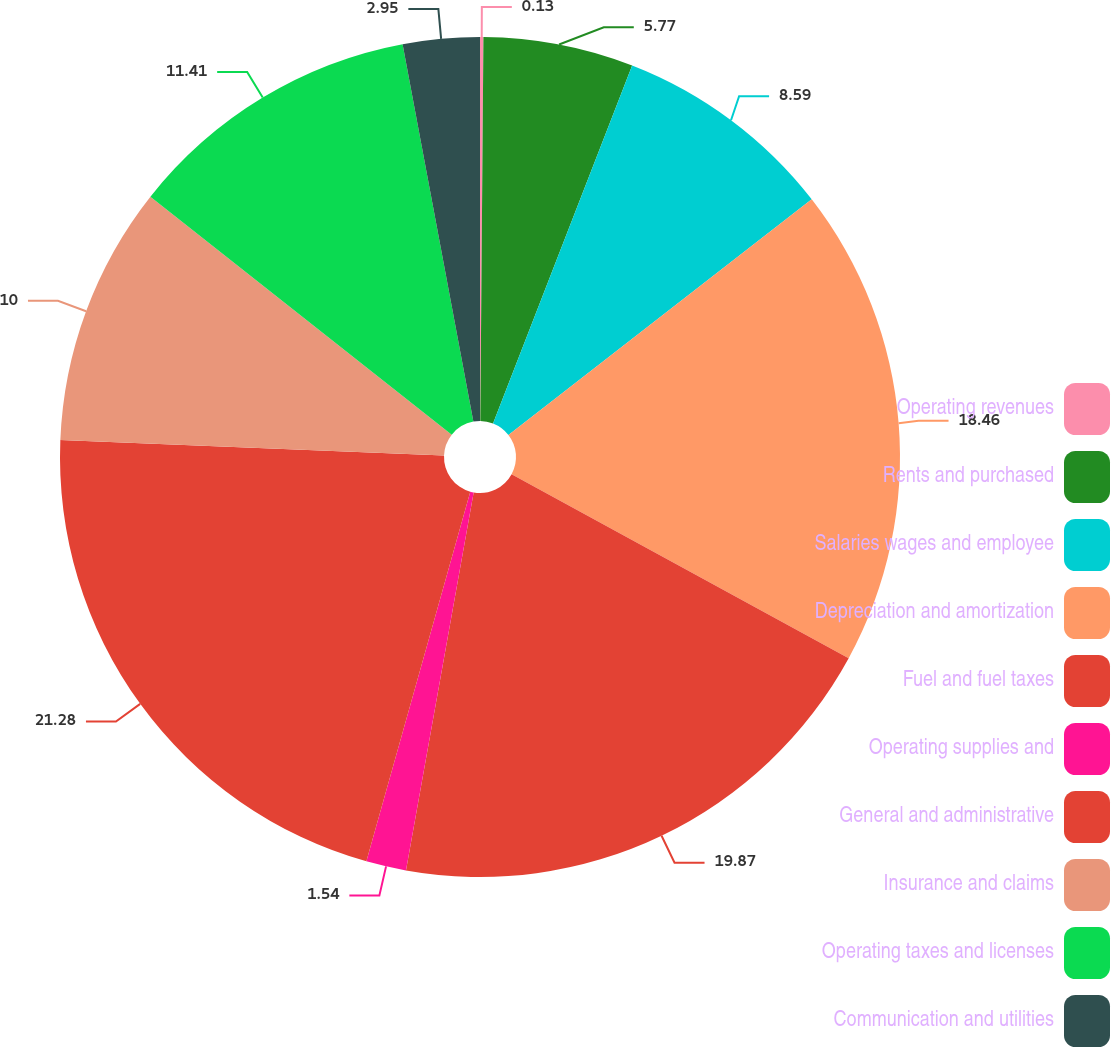Convert chart. <chart><loc_0><loc_0><loc_500><loc_500><pie_chart><fcel>Operating revenues<fcel>Rents and purchased<fcel>Salaries wages and employee<fcel>Depreciation and amortization<fcel>Fuel and fuel taxes<fcel>Operating supplies and<fcel>General and administrative<fcel>Insurance and claims<fcel>Operating taxes and licenses<fcel>Communication and utilities<nl><fcel>0.13%<fcel>5.77%<fcel>8.59%<fcel>18.46%<fcel>19.87%<fcel>1.54%<fcel>21.28%<fcel>10.0%<fcel>11.41%<fcel>2.95%<nl></chart> 